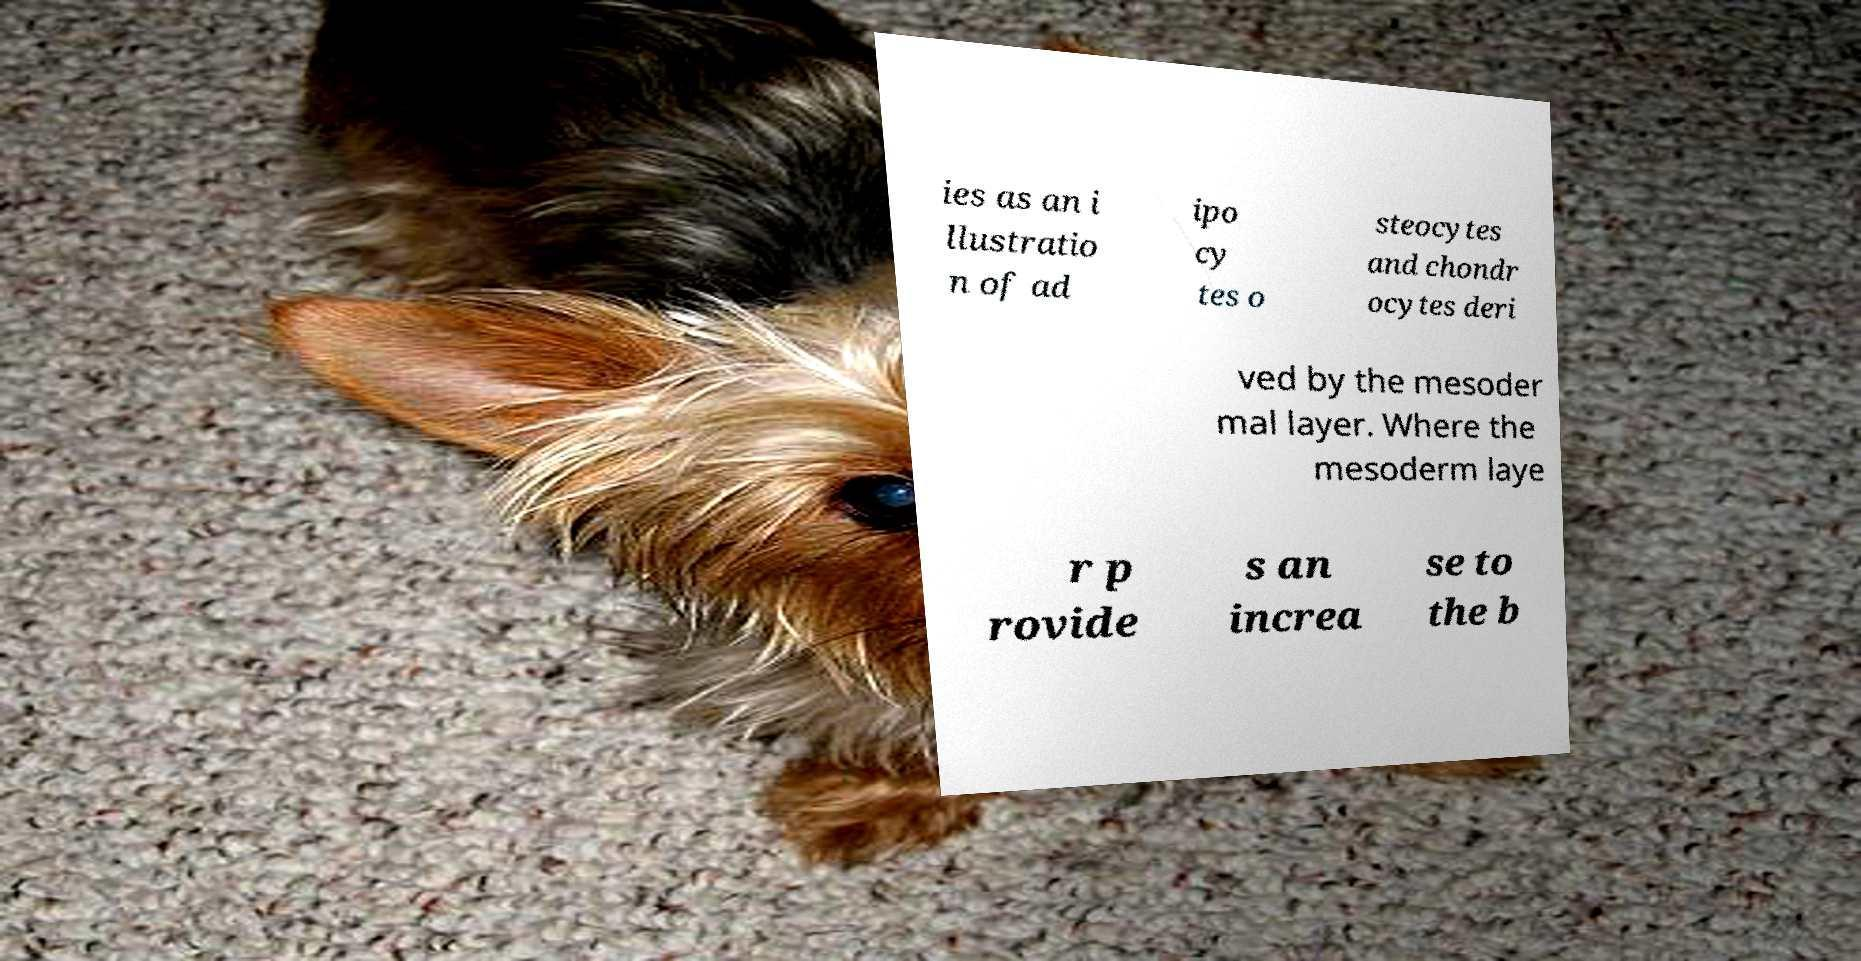Could you assist in decoding the text presented in this image and type it out clearly? ies as an i llustratio n of ad ipo cy tes o steocytes and chondr ocytes deri ved by the mesoder mal layer. Where the mesoderm laye r p rovide s an increa se to the b 